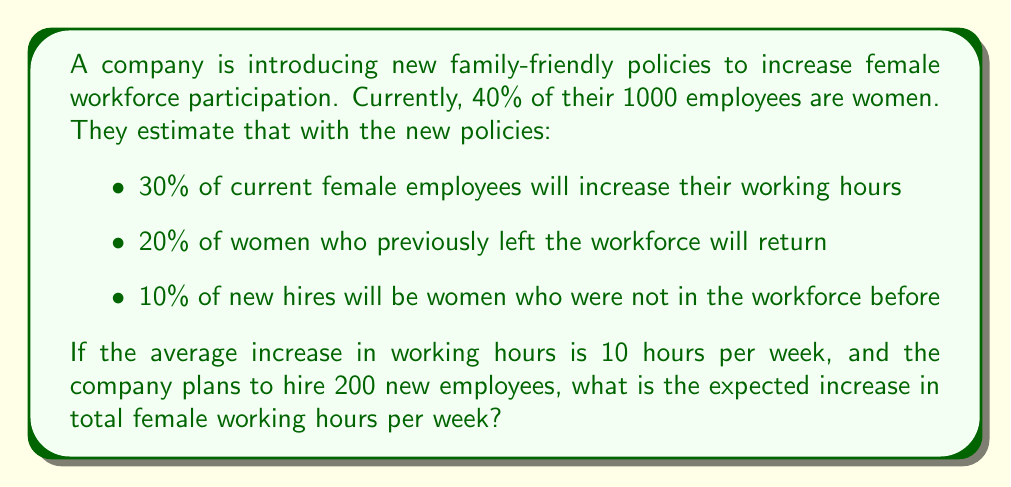Can you solve this math problem? Let's break this down step-by-step:

1. Calculate the number of current female employees:
   $40\% \times 1000 = 400$ women

2. Calculate the increase in hours from current employees:
   $30\% \times 400 = 120$ women
   $120 \times 10 \text{ hours} = 1200$ hours

3. Calculate the number of returning women:
   $20\% \times 400 = 80$ women
   Assuming they work full-time (40 hours/week):
   $80 \times 40 \text{ hours} = 3200$ hours

4. Calculate the number of new female hires from outside the workforce:
   $10\% \times 200 = 20$ women
   Assuming they work full-time:
   $20 \times 40 \text{ hours} = 800$ hours

5. Sum up the total increase in female working hours:
   $1200 + 3200 + 800 = 5200$ hours per week

Therefore, the expected increase in total female working hours per week is 5200 hours.
Answer: 5200 hours per week 